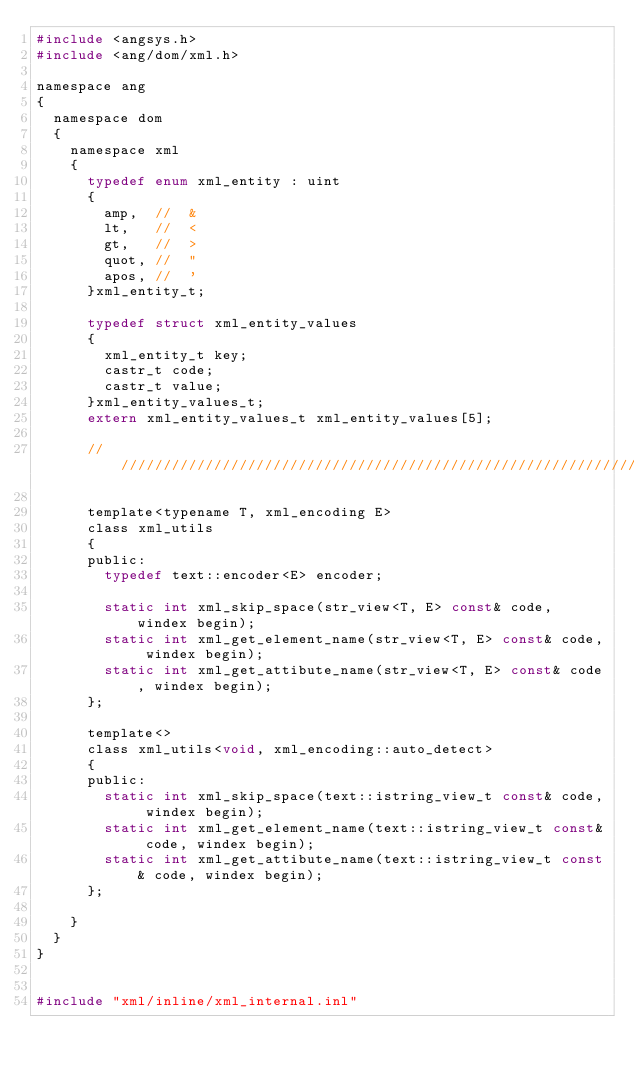<code> <loc_0><loc_0><loc_500><loc_500><_C_>#include <angsys.h>
#include <ang/dom/xml.h>

namespace ang
{
	namespace dom
	{
		namespace xml
		{
			typedef enum xml_entity : uint
			{
				amp,	//	&
				lt,		//	<
				gt,		//	>
				quot,	//	"
				apos,	//	'
			}xml_entity_t;

			typedef	struct xml_entity_values
			{
				xml_entity_t key;
				castr_t	code;
				castr_t	value;
			}xml_entity_values_t;
			extern xml_entity_values_t xml_entity_values[5];

			//////////////////////////////////////////////////////////////////////////////////////////////

			template<typename T, xml_encoding E>
			class xml_utils
			{
			public:
				typedef text::encoder<E> encoder;

				static int xml_skip_space(str_view<T, E> const& code, windex begin);
				static int xml_get_element_name(str_view<T, E> const& code, windex begin);
				static int xml_get_attibute_name(str_view<T, E> const& code, windex begin);
			};

			template<>
			class xml_utils<void, xml_encoding::auto_detect>
			{
			public:
				static int xml_skip_space(text::istring_view_t const& code, windex begin);
				static int xml_get_element_name(text::istring_view_t const& code, windex begin);
				static int xml_get_attibute_name(text::istring_view_t const& code, windex begin);
			};

		}
	}
}


#include "xml/inline/xml_internal.inl"</code> 